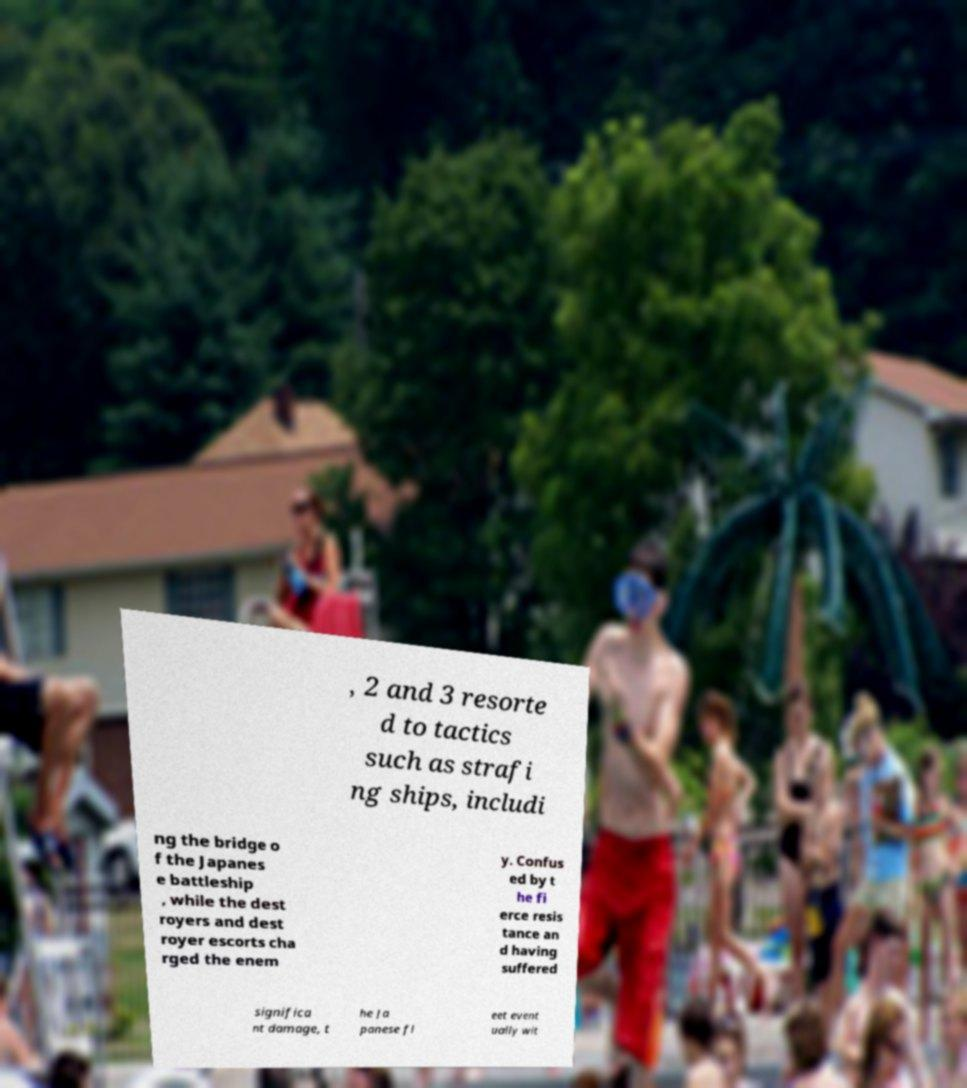What messages or text are displayed in this image? I need them in a readable, typed format. , 2 and 3 resorte d to tactics such as strafi ng ships, includi ng the bridge o f the Japanes e battleship , while the dest royers and dest royer escorts cha rged the enem y. Confus ed by t he fi erce resis tance an d having suffered significa nt damage, t he Ja panese fl eet event ually wit 